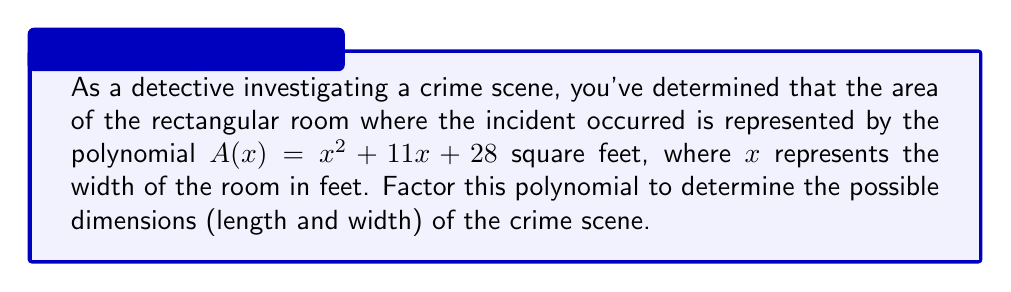Could you help me with this problem? To solve this problem, we need to factor the quadratic equation $A(x) = x^2 + 11x + 28$. This will give us two factors that represent the length and width of the room.

Step 1: Identify the coefficients
$a = 1$, $b = 11$, and $c = 28$

Step 2: Find two numbers that multiply to give $ac$ (which is 28) and add up to $b$ (which is 11)
The numbers that satisfy this are 4 and 7, since $4 \times 7 = 28$ and $4 + 7 = 11$

Step 3: Rewrite the middle term using these numbers
$x^2 + 11x + 28 = x^2 + 4x + 7x + 28$

Step 4: Group the terms and factor by pairs
$(x^2 + 4x) + (7x + 28)$
$x(x + 4) + 7(x + 4)$

Step 5: Factor out the common factor $(x + 4)$
$(x + 4)(x + 7)$

Therefore, the factored form of the polynomial is $(x + 4)(x + 7)$

In the context of the crime scene:
- The width of the room is $x$ feet
- The length of the room is $(x + 7)$ feet
- The other factor, $(x + 4)$, when set to zero, gives us the negative value of the width: $x = -4$

Since room dimensions cannot be negative, we use the positive root. This means the width of the room is 4 feet and the length is $4 + 7 = 11$ feet.
Answer: The possible dimensions of the crime scene are 4 feet wide by 11 feet long. 